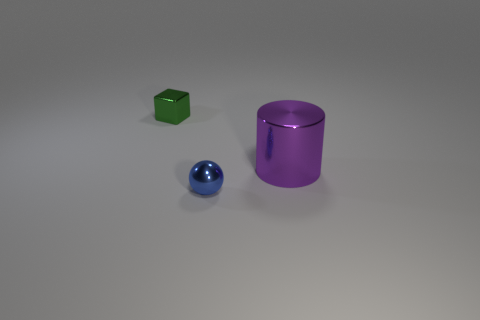What is the size of the green thing that is made of the same material as the blue thing?
Keep it short and to the point. Small. Is the number of tiny objects that are on the left side of the small blue sphere greater than the number of tiny blue metallic balls behind the large purple shiny object?
Make the answer very short. Yes. Is the color of the large thing the same as the object to the left of the tiny blue thing?
Your answer should be very brief. No. There is a object that is the same size as the ball; what is its material?
Offer a very short reply. Metal. How many things are either small blue balls or large purple cylinders right of the green metallic cube?
Provide a succinct answer. 2. Does the green cube have the same size as the metal thing that is right of the metal sphere?
Offer a very short reply. No. How many cylinders are either blue objects or small cyan shiny things?
Ensure brevity in your answer.  0. What number of objects are both on the right side of the ball and in front of the purple cylinder?
Offer a very short reply. 0. What number of other objects are the same color as the big metal thing?
Your answer should be compact. 0. There is a thing to the right of the small blue metallic object; what shape is it?
Your answer should be very brief. Cylinder. 